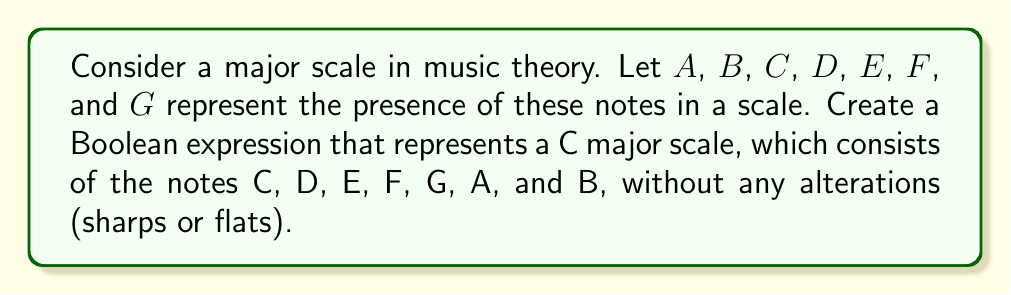Can you answer this question? To create a Boolean expression for a C major scale, we need to consider the presence or absence of each note:

1. C is present, so we include $C$
2. D is present, so we include $D$
3. E is present, so we include $E$
4. F is present, so we include $F$
5. G is present, so we include $G$
6. A is present, so we include $A$
7. B is present, so we include $B$

In Boolean algebra, the AND operation is represented by multiplication or the $\wedge$ symbol. Since all these notes are present in the C major scale, we need to use the AND operation to combine them.

The resulting Boolean expression is:

$$C \wedge D \wedge E \wedge F \wedge G \wedge A \wedge B$$

This expression will evaluate to true (1) only when all the variables are true (1), representing the presence of all these notes in the C major scale.
Answer: $C \wedge D \wedge E \wedge F \wedge G \wedge A \wedge B$ 